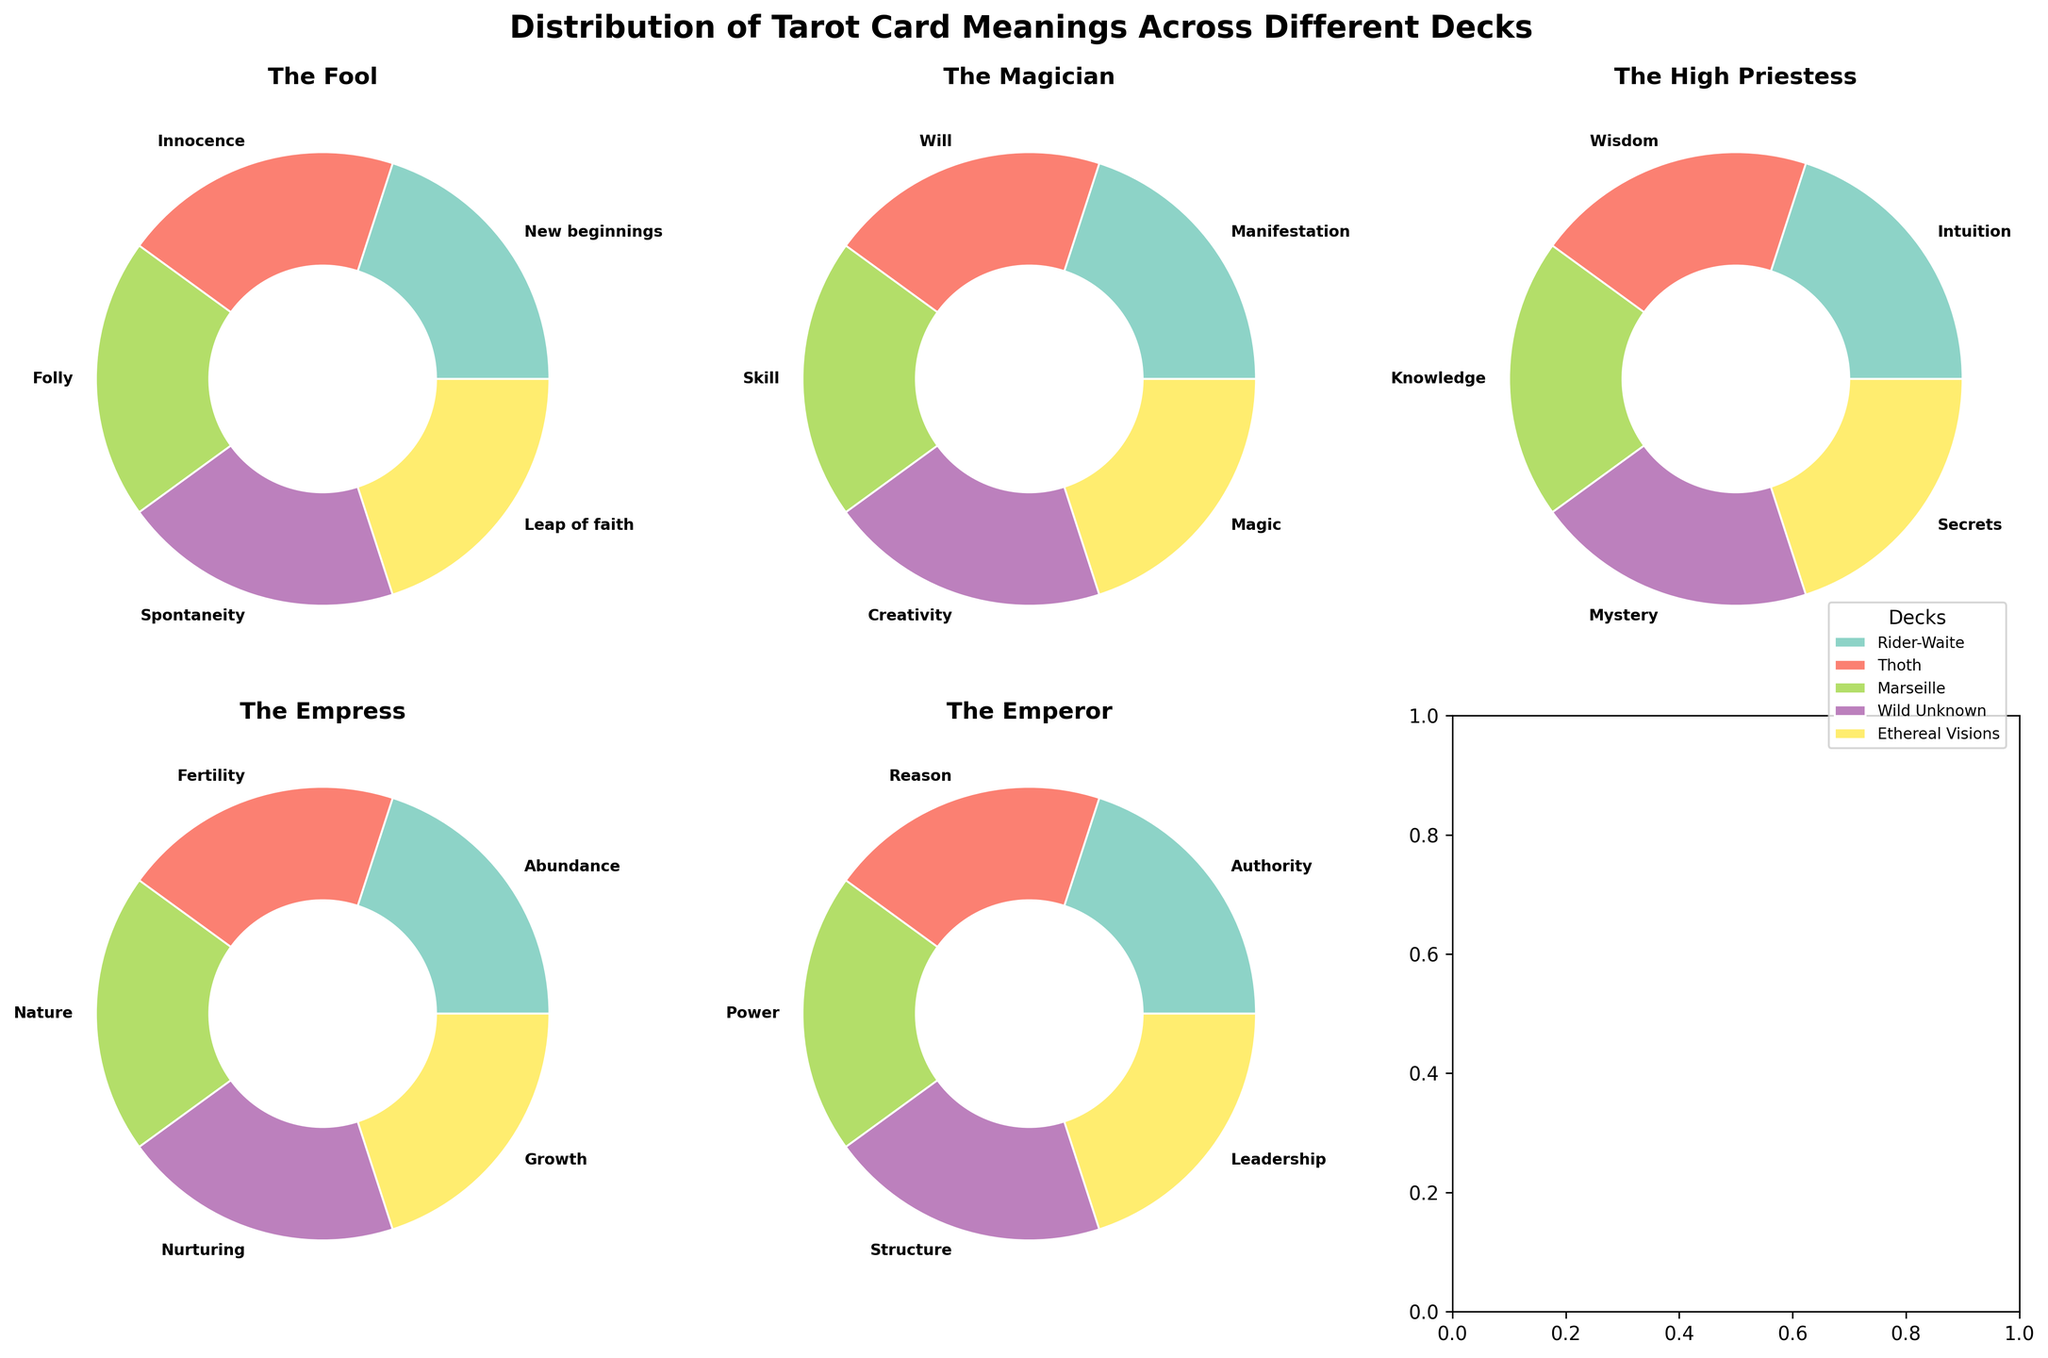Which tarot card has a pie chart with segments labeled "Leap of faith", "Magic", "Secrets", "Growth", and "Leadership"? This question asks for identification based on the labels in the pie chart segments. The labels mentioned ("Leap of faith", "Magic", "Secrets", "Growth", and "Leadership") correspond to the Ethereal Visions deck, which appear in the pie chart for "The Fool", "The Magician", "The High Priestess", "The Empress", and "The Emperor".
Answer: The Ethereal Visions deck has these labels How many tarot cards are represented in the subplot? This requires counting the number of subplots, each representing a tarot card. The figure has 2 rows and 3 columns of subplots, and each subplot shows a different tarot card's distribution. There are 5 cards total: "The Fool", "The Magician", "The High Priestess", "The Empress", and "The Emperor".
Answer: 5 tarot cards Which deck's meaning for The Fool is "Innocence"? This asks for a specific detail from one of the pie chart segments in the subplot dedicated to "The Fool". By checking the labels in the subplot for "The Fool", we see that "Innocence" is associated with the Thoth deck.
Answer: Thoth Which tarot card's subplot contains a segment labeled "Structures"? This question requires identifying the specific segment in one of the subplots. By examining the labels, "Structures" appears in the subplot for "The Emperor" under the Wild Unknown deck.
Answer: The Emperor What is the title of the entire figure? This involves simply reading the main title of the figure. The title is "Distribution of Tarot Card Meanings Across Different Decks".
Answer: Distribution of Tarot Card Meanings Across Different Decks Compare the meaning of The Magician card in the Rider-Waite and Marseille decks. This asks to compare the labels from two specific segments in the pie chart for "The Magician". For Rider-Waite, the label is "Manifestation", and for Marseille, it's "Skill".
Answer: Rider-Waite: Manifestation, Marseille: Skill What are the meanings associated with The High Priestess across all decks? This requires listing out the labels found in the subplot for "The High Priestess". The labels are "Intuition" (Rider-Waite), "Wisdom" (Thoth), "Knowledge" (Marseille), "Mystery" (Wild Unknown), and "Secrets" (Ethereal Visions).
Answer: Intuition, Wisdom, Knowledge, Mystery, Secrets Which tarot card's meaning is labeled "Authority" in the Rider-Waite deck? Identify the specific segment based on the label and deck. The card with "Authority" in the Rider-Waite deck is "The Emperor".
Answer: The Emperor Which decks label The Empress with meanings related to growth or fertility? This requires cross-referencing the labels of "The Empress" subplot against growth or fertility-related keywords. The Thoth deck uses "Fertility" and Ethereal Visions uses "Growth".
Answer: Thoth (Fertility), Ethereal Visions (Growth) Identify the deck and meaning of "Secrets" among the tarot cards. This asks to find which segment of the pie chart for each card has the "Secrets" label. "Secrets" is associated with The High Priestess card in the Ethereal Visions deck.
Answer: Ethereal Visions, The High Priestess 